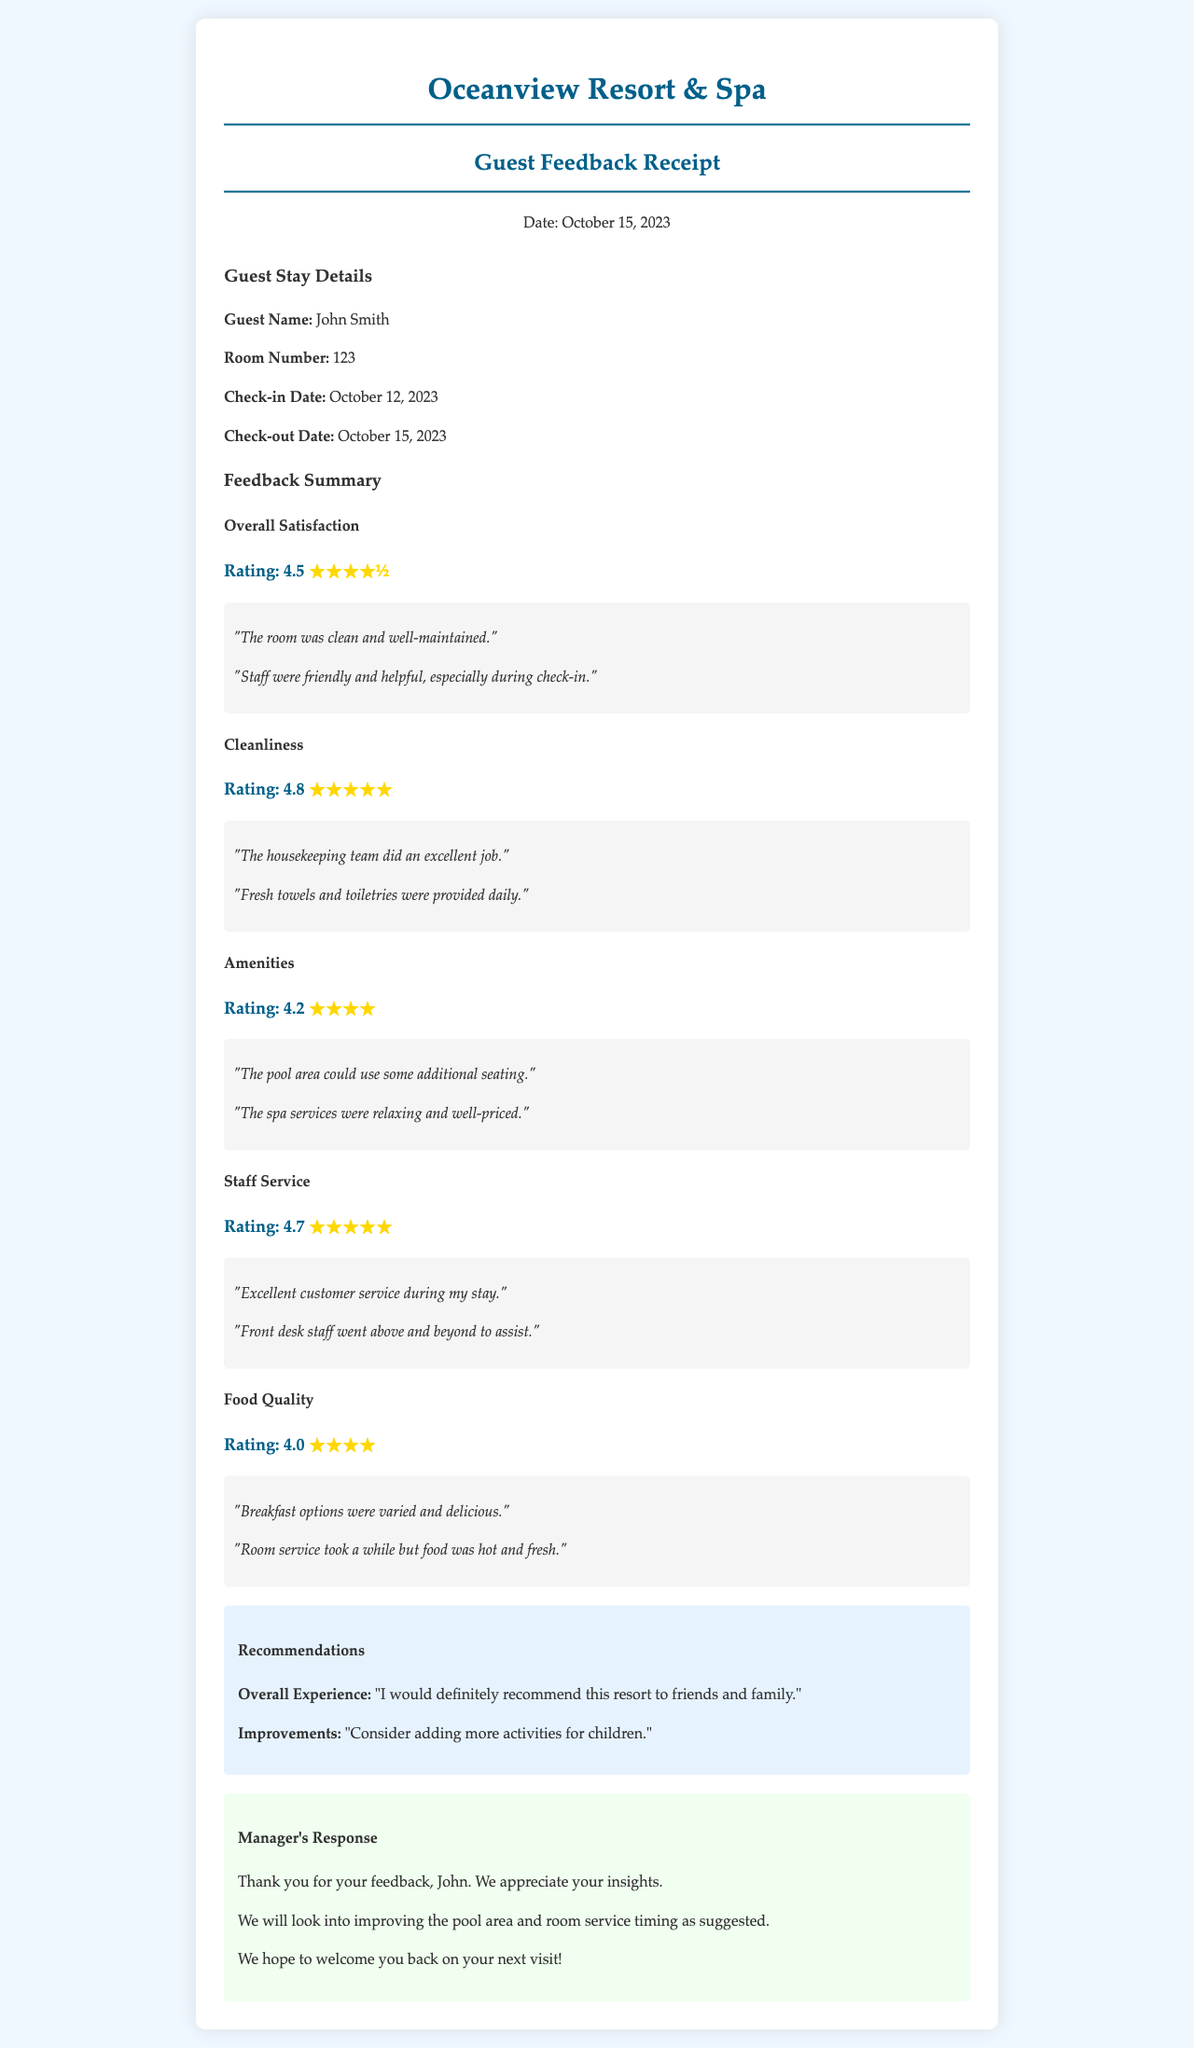What is the guest's name? The guest's name is listed in the "Guest Stay Details" section of the document.
Answer: John Smith What was the check-in date? The check-in date can be found in the same section where the guest's details are provided.
Answer: October 12, 2023 What was the rating for cleanliness? The cleanliness rating is mentioned under the "Cleanliness" feedback summary.
Answer: 4.8 What is one of the recommendations for improvement? The recommendations section provides insights on areas to improve, specifically a suggestion from the guest.
Answer: Consider adding more activities for children What was the guest's overall satisfaction rating? The overall satisfaction rating is specifically highlighted in the feedback summary section.
Answer: 4.5 What did the guest say about staff service? The comments provided under staff service display the guest's opinion on the service received.
Answer: Excellent customer service during my stay Which area did the guest suggest could use improvements? The feedback summary includes specific areas where the guest noted improvement opportunities.
Answer: Pool area What was the feedback about food quality? The document contains comments that summarize the guest's views on the food quality offered during their stay.
Answer: Breakfast options were varied and delicious What did the manager respond to the guest's feedback? The manager's response includes key reactions to the feedback provided by the guest.
Answer: We will look into improving the pool area and room service timing as suggested 